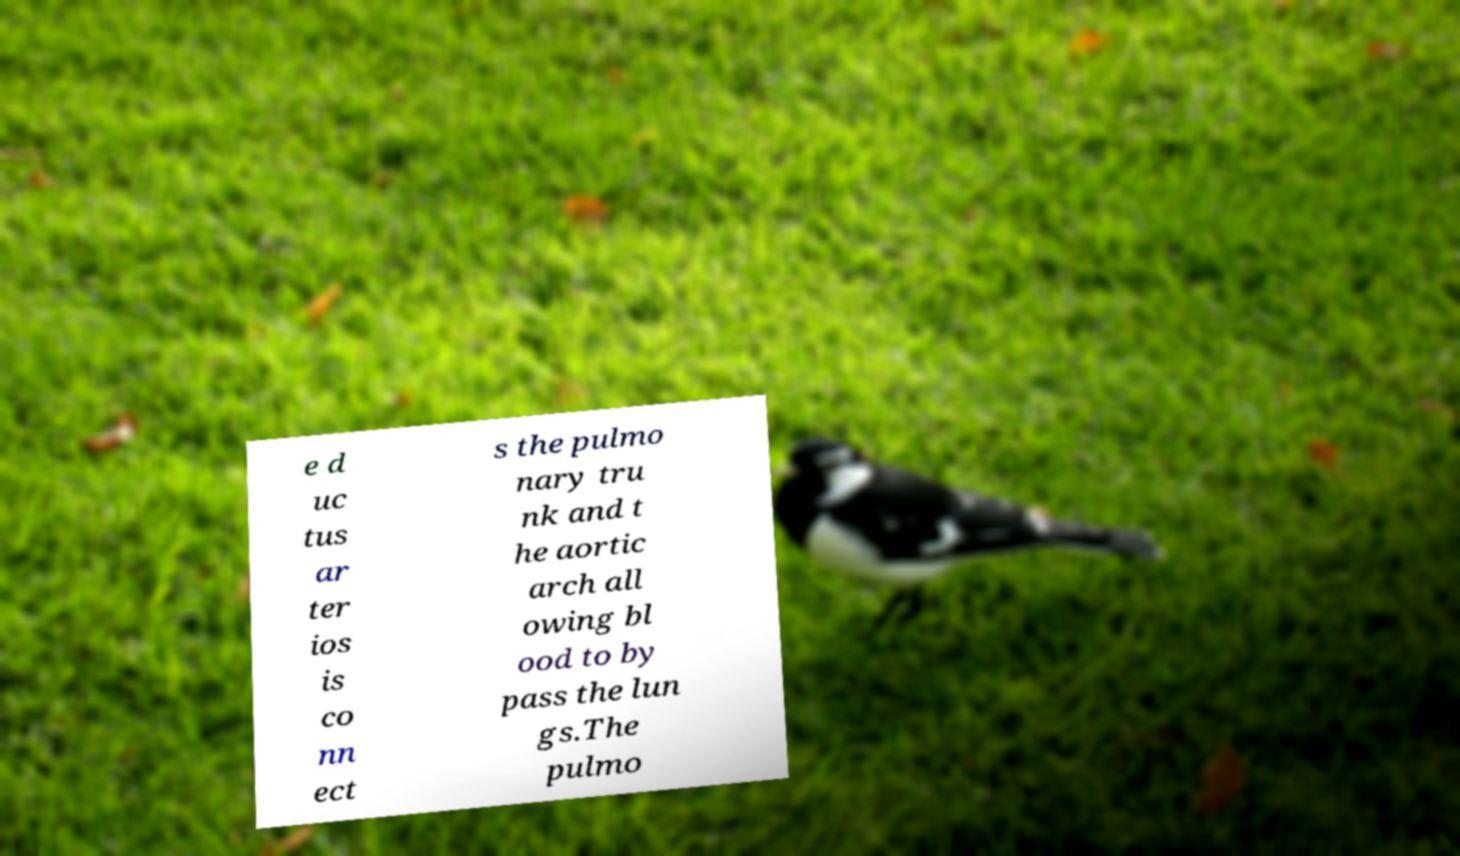Please read and relay the text visible in this image. What does it say? e d uc tus ar ter ios is co nn ect s the pulmo nary tru nk and t he aortic arch all owing bl ood to by pass the lun gs.The pulmo 